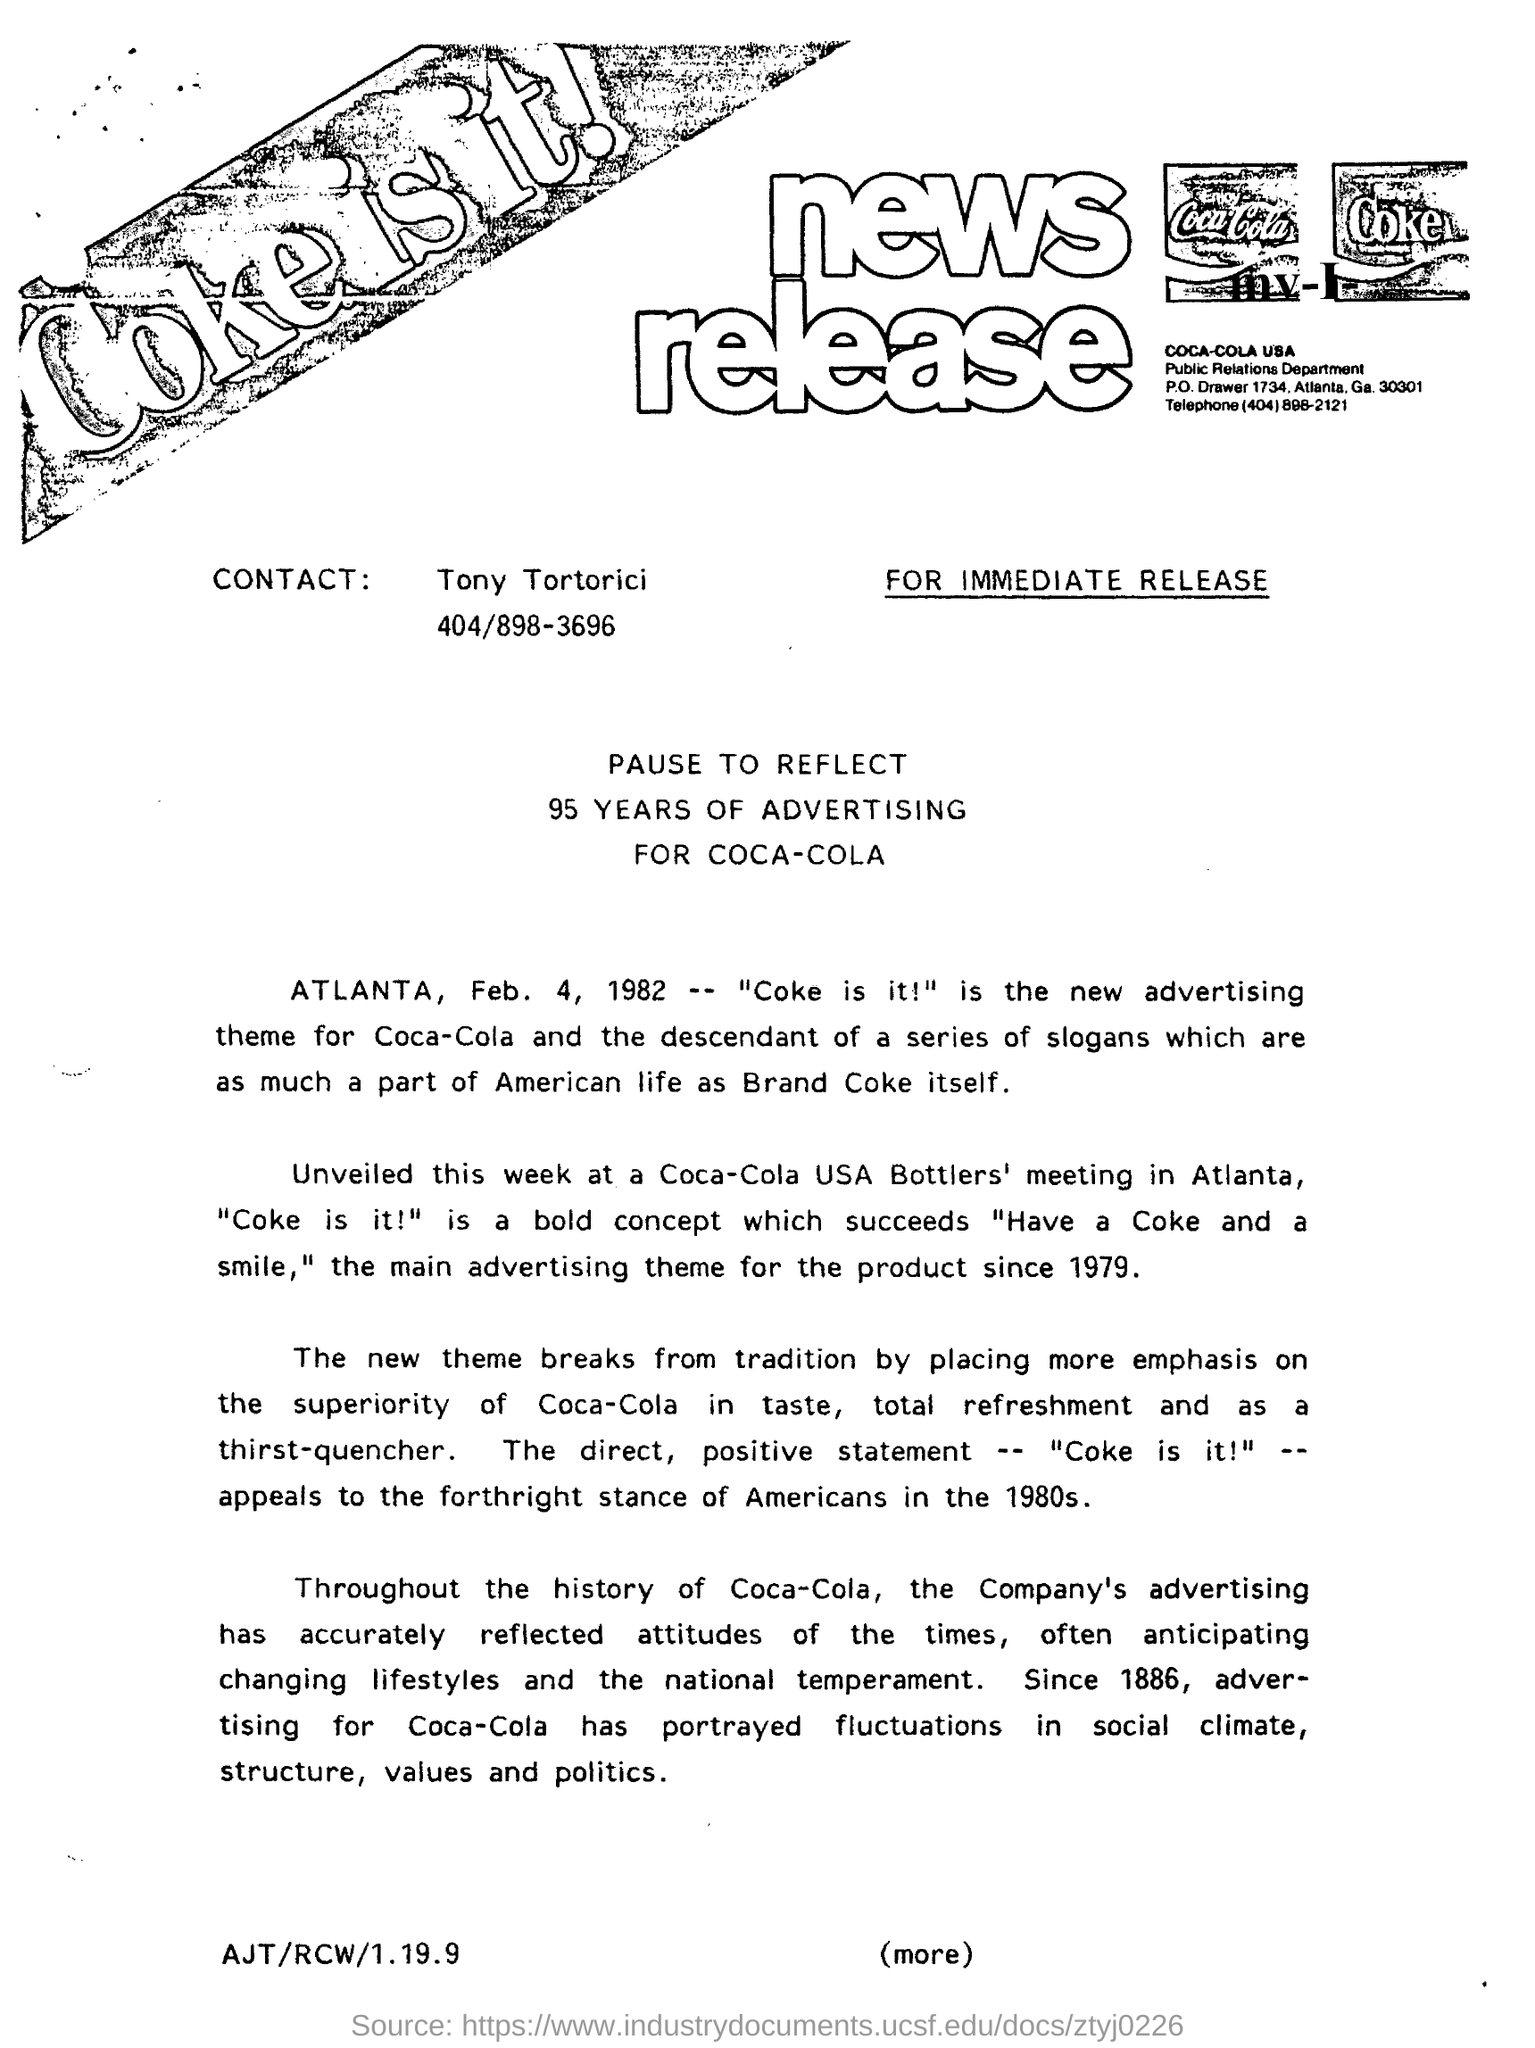H ow many years of advertising is mentioned?
Keep it short and to the point. 95 years. What is the date mentioned?
Offer a terse response. Feb. 4, 1982. Whose name is mentioned to  Contact?
Your answer should be very brief. Tony tortorici. 